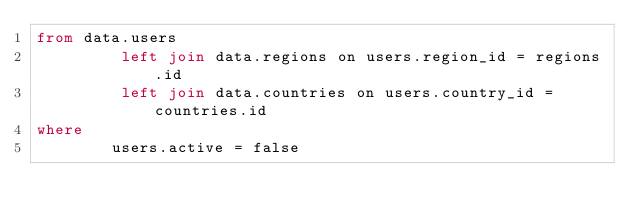<code> <loc_0><loc_0><loc_500><loc_500><_SQL_>from data.users
         left join data.regions on users.region_id = regions.id
         left join data.countries on users.country_id = countries.id
where
        users.active = false
</code> 